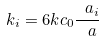<formula> <loc_0><loc_0><loc_500><loc_500>k _ { i } = 6 k c _ { 0 } \frac { \ a _ { i } } { \ a }</formula> 